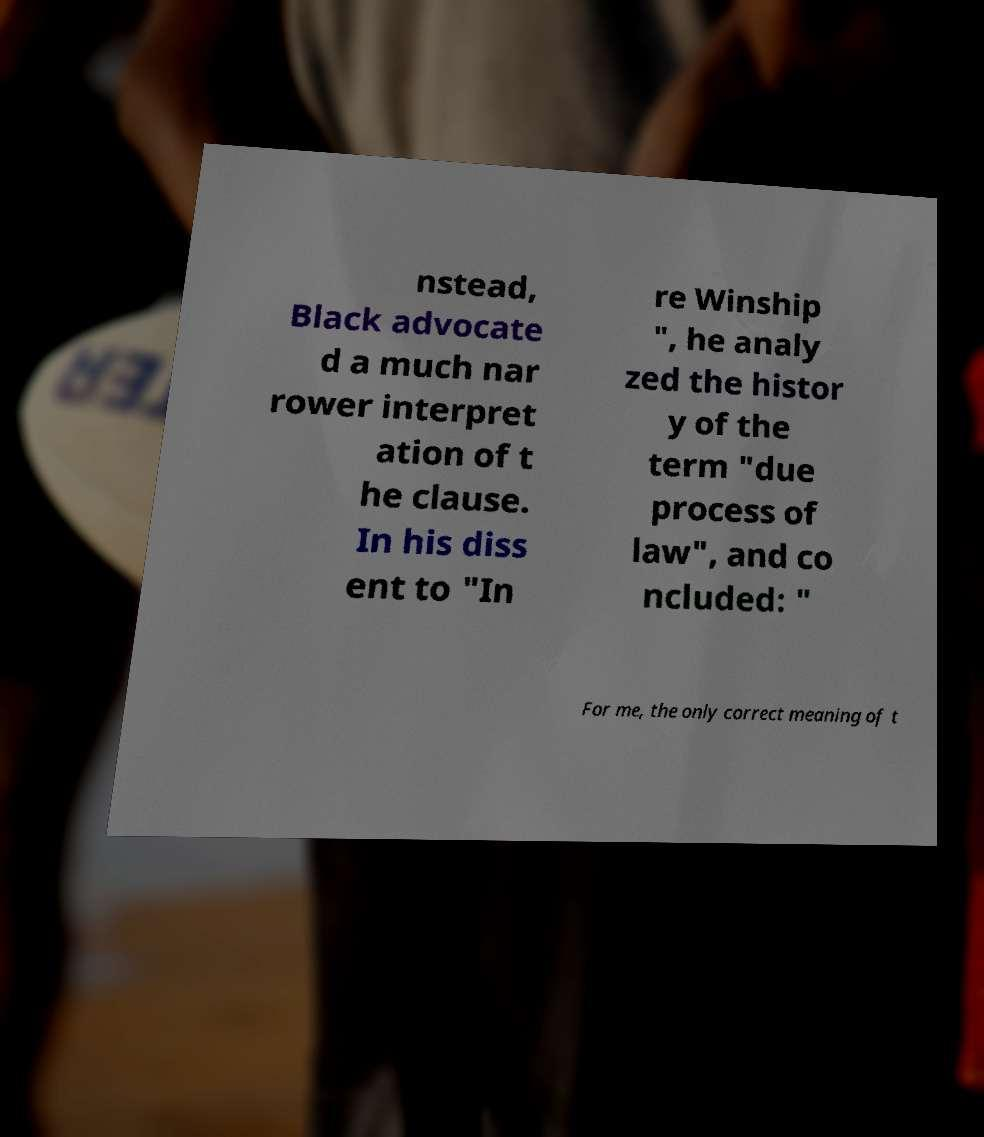What messages or text are displayed in this image? I need them in a readable, typed format. nstead, Black advocate d a much nar rower interpret ation of t he clause. In his diss ent to "In re Winship ", he analy zed the histor y of the term "due process of law", and co ncluded: " For me, the only correct meaning of t 